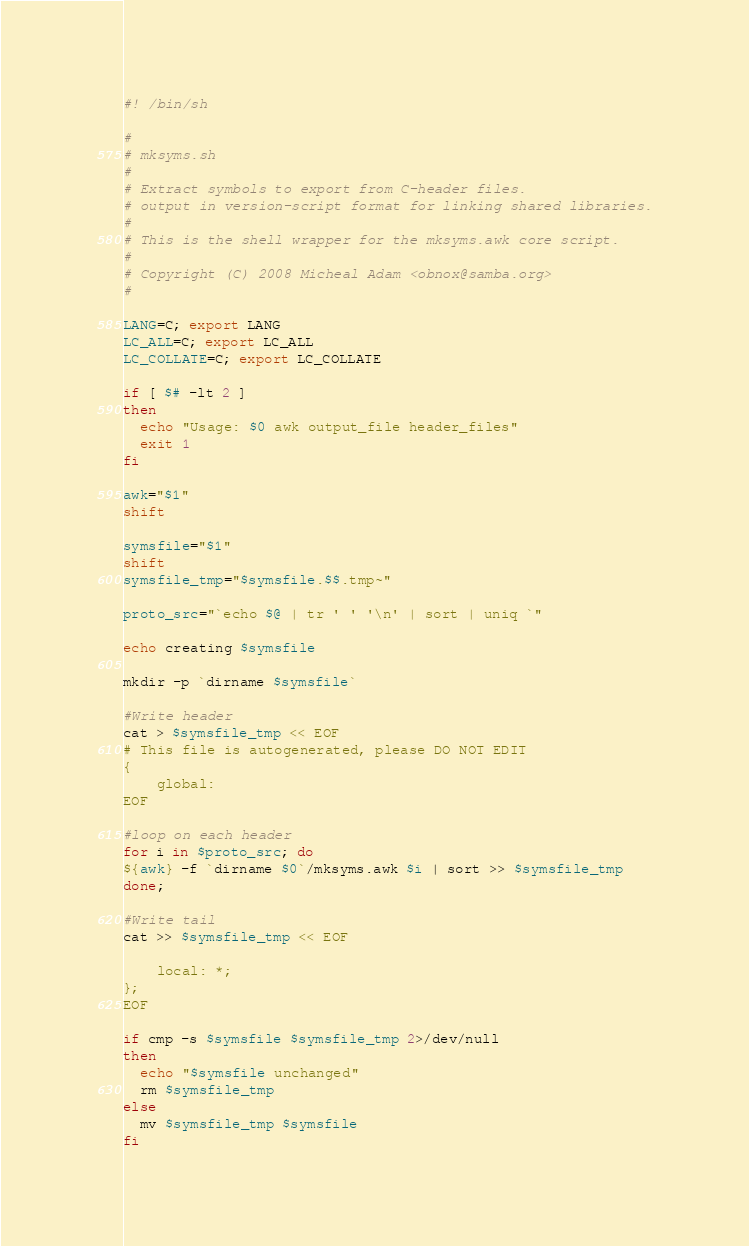<code> <loc_0><loc_0><loc_500><loc_500><_Bash_>#! /bin/sh

#
# mksyms.sh
#
# Extract symbols to export from C-header files.
# output in version-script format for linking shared libraries.
#
# This is the shell wrapper for the mksyms.awk core script.
#
# Copyright (C) 2008 Micheal Adam <obnox@samba.org>
#

LANG=C; export LANG
LC_ALL=C; export LC_ALL
LC_COLLATE=C; export LC_COLLATE

if [ $# -lt 2 ]
then
  echo "Usage: $0 awk output_file header_files"
  exit 1
fi

awk="$1"
shift

symsfile="$1"
shift
symsfile_tmp="$symsfile.$$.tmp~"

proto_src="`echo $@ | tr ' ' '\n' | sort | uniq `"

echo creating $symsfile

mkdir -p `dirname $symsfile`

#Write header
cat > $symsfile_tmp << EOF
# This file is autogenerated, please DO NOT EDIT
{
    global:
EOF

#loop on each header
for i in $proto_src; do
${awk} -f `dirname $0`/mksyms.awk $i | sort >> $symsfile_tmp
done;

#Write tail
cat >> $symsfile_tmp << EOF

    local: *;
};
EOF

if cmp -s $symsfile $symsfile_tmp 2>/dev/null
then
  echo "$symsfile unchanged"
  rm $symsfile_tmp
else
  mv $symsfile_tmp $symsfile
fi
</code> 